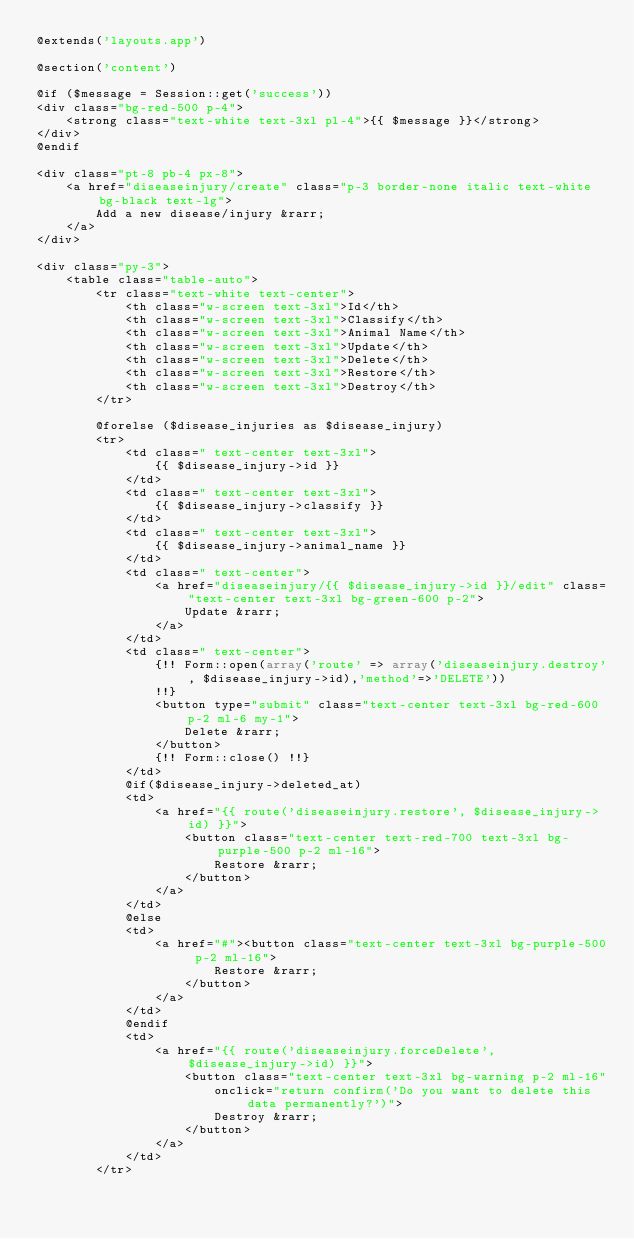<code> <loc_0><loc_0><loc_500><loc_500><_PHP_>@extends('layouts.app')

@section('content')

@if ($message = Session::get('success'))
<div class="bg-red-500 p-4">
    <strong class="text-white text-3xl pl-4">{{ $message }}</strong>
</div>
@endif

<div class="pt-8 pb-4 px-8">
    <a href="diseaseinjury/create" class="p-3 border-none italic text-white bg-black text-lg">
        Add a new disease/injury &rarr;
    </a>
</div>

<div class="py-3">
    <table class="table-auto">
        <tr class="text-white text-center">
            <th class="w-screen text-3xl">Id</th>
            <th class="w-screen text-3xl">Classify</th>
            <th class="w-screen text-3xl">Animal Name</th>
            <th class="w-screen text-3xl">Update</th>
            <th class="w-screen text-3xl">Delete</th>
            <th class="w-screen text-3xl">Restore</th>
            <th class="w-screen text-3xl">Destroy</th>
        </tr>

        @forelse ($disease_injuries as $disease_injury)
        <tr>
            <td class=" text-center text-3xl">
                {{ $disease_injury->id }}
            </td>
            <td class=" text-center text-3xl">
                {{ $disease_injury->classify }}
            </td>
            <td class=" text-center text-3xl">
                {{ $disease_injury->animal_name }}
            </td>
            <td class=" text-center">
                <a href="diseaseinjury/{{ $disease_injury->id }}/edit" class="text-center text-3xl bg-green-600 p-2">
                    Update &rarr;
                </a>
            </td>
            <td class=" text-center">
                {!! Form::open(array('route' => array('diseaseinjury.destroy', $disease_injury->id),'method'=>'DELETE'))
                !!}
                <button type="submit" class="text-center text-3xl bg-red-600 p-2 ml-6 my-1">
                    Delete &rarr;
                </button>
                {!! Form::close() !!}
            </td>
            @if($disease_injury->deleted_at)
            <td>
                <a href="{{ route('diseaseinjury.restore', $disease_injury->id) }}">
                    <button class="text-center text-red-700 text-3xl bg-purple-500 p-2 ml-16">
                        Restore &rarr;
                    </button>
                </a>
            </td>
            @else
            <td>
                <a href="#"><button class="text-center text-3xl bg-purple-500 p-2 ml-16">
                        Restore &rarr;
                    </button>
                </a>
            </td>
            @endif
            <td>
                <a href="{{ route('diseaseinjury.forceDelete', $disease_injury->id) }}">
                    <button class="text-center text-3xl bg-warning p-2 ml-16"
                        onclick="return confirm('Do you want to delete this data permanently?')">
                        Destroy &rarr;
                    </button>
                </a>
            </td>
        </tr></code> 